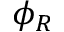Convert formula to latex. <formula><loc_0><loc_0><loc_500><loc_500>\phi _ { R }</formula> 